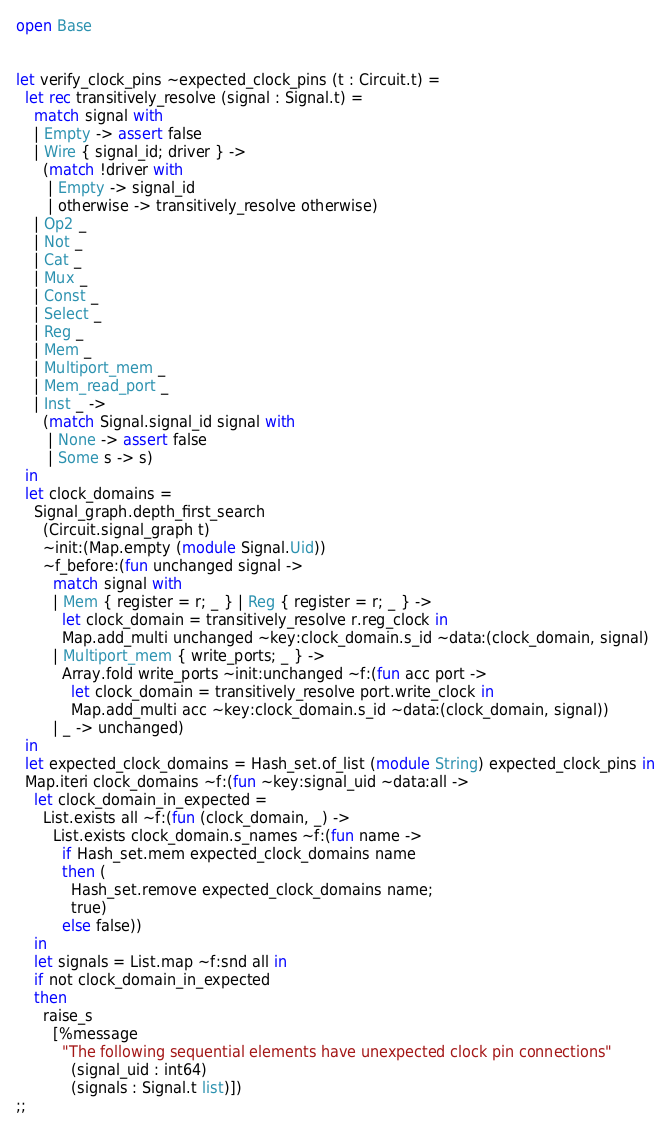Convert code to text. <code><loc_0><loc_0><loc_500><loc_500><_OCaml_>open Base


let verify_clock_pins ~expected_clock_pins (t : Circuit.t) =
  let rec transitively_resolve (signal : Signal.t) =
    match signal with
    | Empty -> assert false
    | Wire { signal_id; driver } ->
      (match !driver with
       | Empty -> signal_id
       | otherwise -> transitively_resolve otherwise)
    | Op2 _
    | Not _
    | Cat _
    | Mux _
    | Const _
    | Select _
    | Reg _
    | Mem _
    | Multiport_mem _
    | Mem_read_port _
    | Inst _ ->
      (match Signal.signal_id signal with
       | None -> assert false
       | Some s -> s)
  in
  let clock_domains =
    Signal_graph.depth_first_search
      (Circuit.signal_graph t)
      ~init:(Map.empty (module Signal.Uid))
      ~f_before:(fun unchanged signal ->
        match signal with
        | Mem { register = r; _ } | Reg { register = r; _ } ->
          let clock_domain = transitively_resolve r.reg_clock in
          Map.add_multi unchanged ~key:clock_domain.s_id ~data:(clock_domain, signal)
        | Multiport_mem { write_ports; _ } ->
          Array.fold write_ports ~init:unchanged ~f:(fun acc port ->
            let clock_domain = transitively_resolve port.write_clock in
            Map.add_multi acc ~key:clock_domain.s_id ~data:(clock_domain, signal))
        | _ -> unchanged)
  in
  let expected_clock_domains = Hash_set.of_list (module String) expected_clock_pins in
  Map.iteri clock_domains ~f:(fun ~key:signal_uid ~data:all ->
    let clock_domain_in_expected =
      List.exists all ~f:(fun (clock_domain, _) ->
        List.exists clock_domain.s_names ~f:(fun name ->
          if Hash_set.mem expected_clock_domains name
          then (
            Hash_set.remove expected_clock_domains name;
            true)
          else false))
    in
    let signals = List.map ~f:snd all in
    if not clock_domain_in_expected
    then
      raise_s
        [%message
          "The following sequential elements have unexpected clock pin connections"
            (signal_uid : int64)
            (signals : Signal.t list)])
;;
</code> 